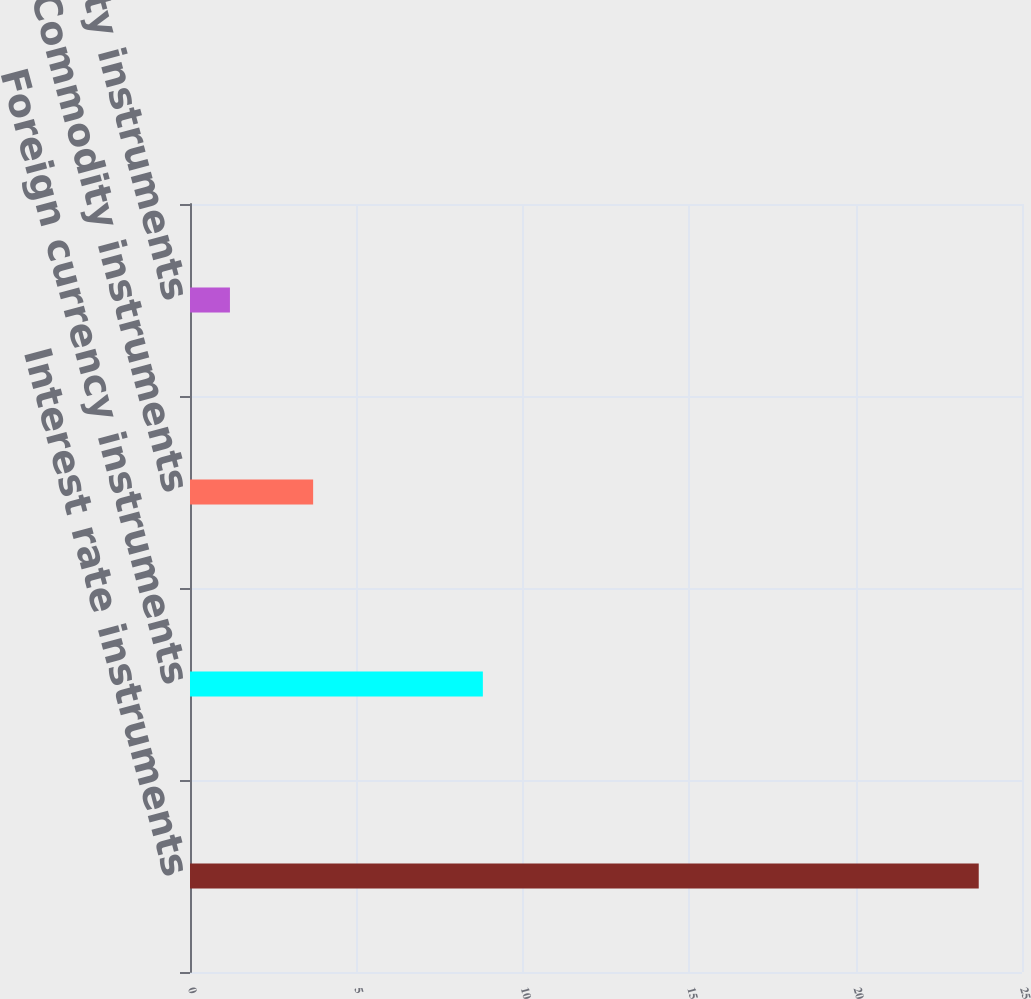Convert chart. <chart><loc_0><loc_0><loc_500><loc_500><bar_chart><fcel>Interest rate instruments<fcel>Foreign currency instruments<fcel>Commodity instruments<fcel>Equity instruments<nl><fcel>23.7<fcel>8.8<fcel>3.7<fcel>1.2<nl></chart> 